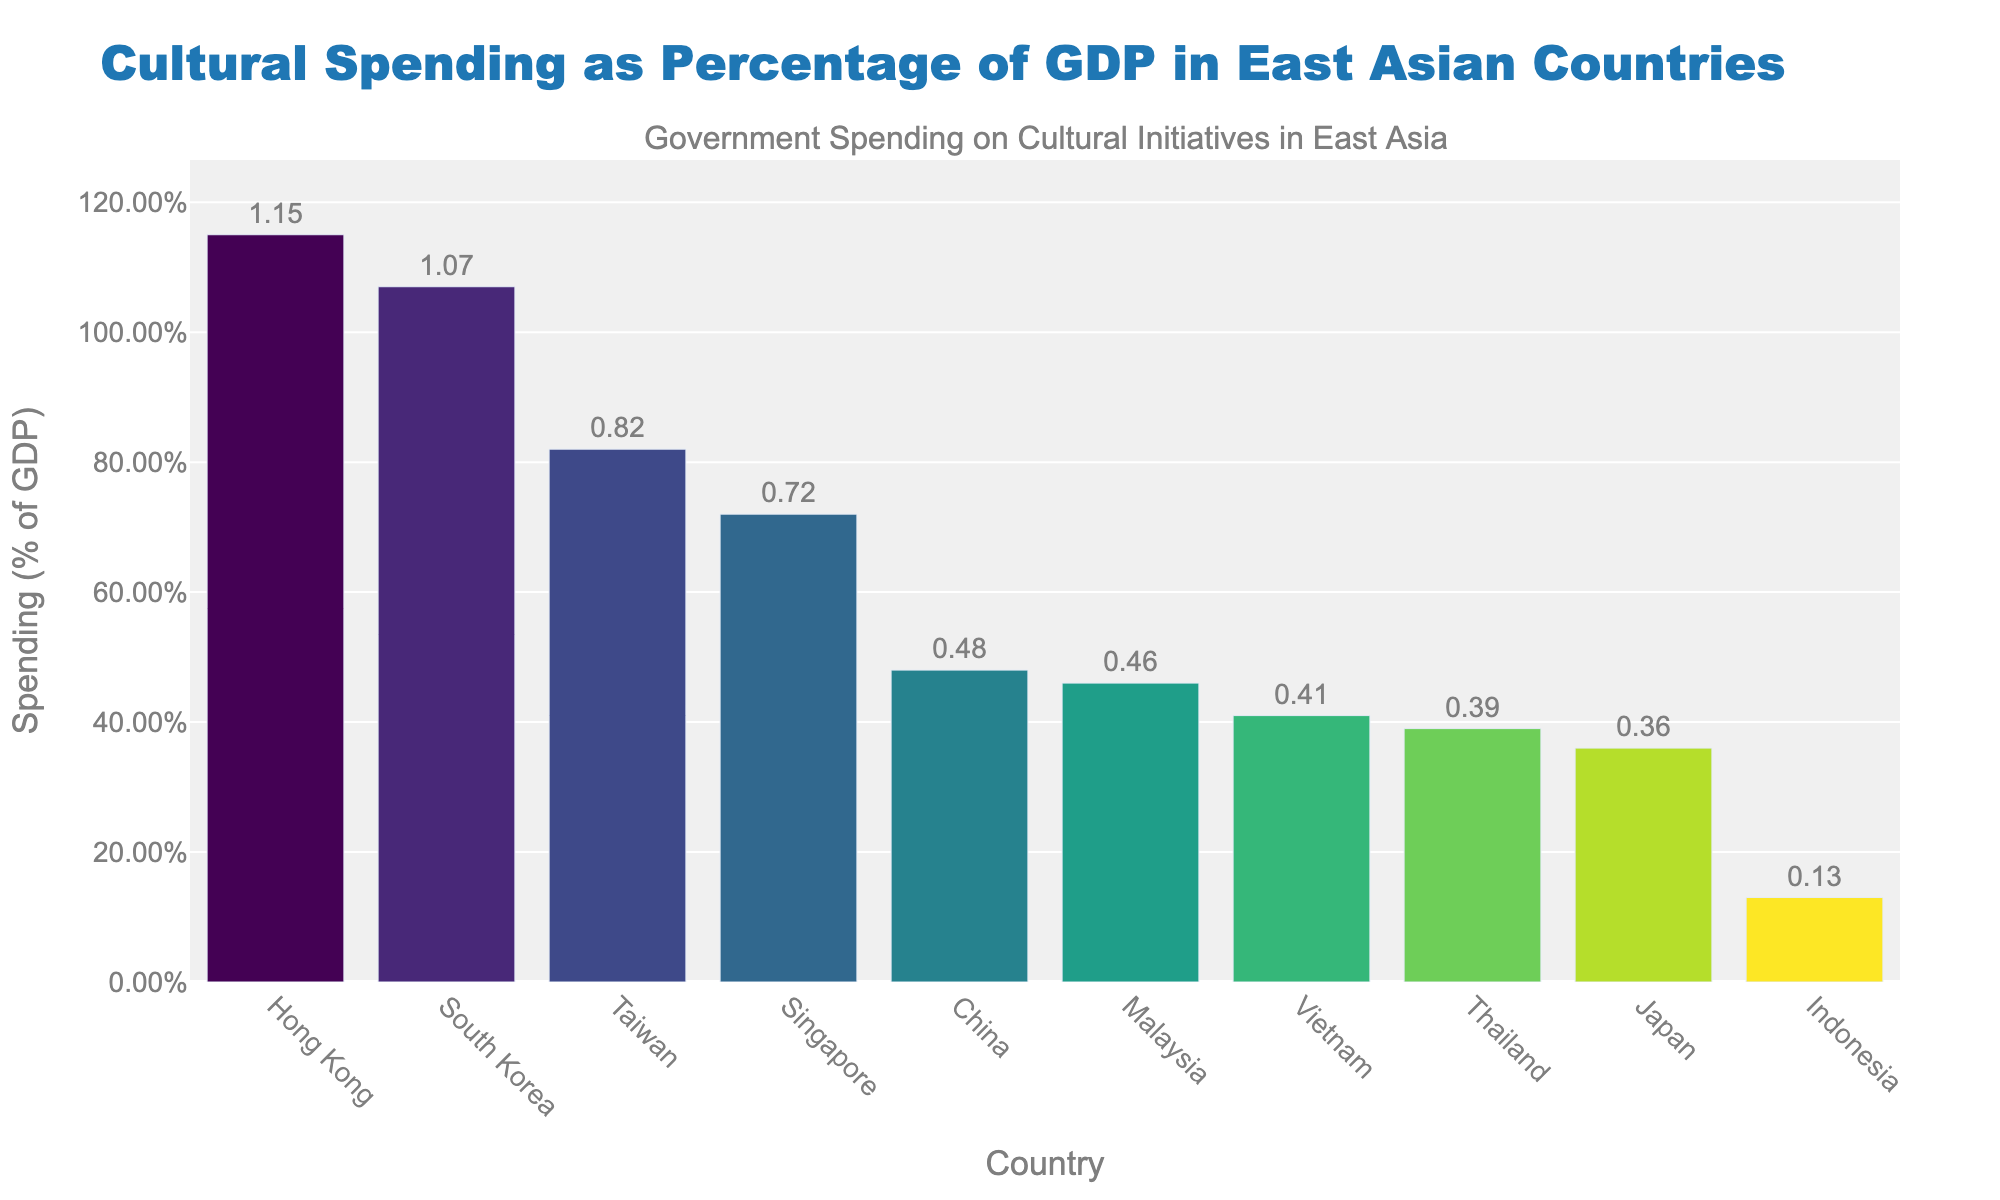What country has the highest government spending on cultural initiatives as a percentage of GDP? The country with the tallest bar represents the highest spending. Hong Kong has the tallest bar.
Answer: Hong Kong Which country has the lowest government spending on cultural initiatives as a percentage of GDP? The country with the shortest bar represents the lowest spending. Indonesia has the shortest bar.
Answer: Indonesia What is the difference in government spending on cultural initiatives between South Korea and Japan? Find the heights of the bars for South Korea (1.07%) and Japan (0.36%) and subtract the smaller from the larger. 1.07% - 0.36% = 0.71%.
Answer: 0.71% Which countries have government spending close to 0.4% of GDP? Look for bars around the 0.4% mark. Vietnam (0.41%), Thailand (0.39%), and Malaysia (0.46%) are close to this value.
Answer: Vietnam, Thailand, Malaysia What is the average government spending on cultural initiatives for China, Japan, and South Korea? Add the values for China (0.48%), Japan (0.36%), and South Korea (1.07%), then divide by 3. (0.48% + 0.36% + 1.07%) / 3 = 0.6367%.
Answer: 0.64% How much more does Hong Kong spend on cultural initiatives compared to Vietnam? Find the heights of the bars for Hong Kong (1.15%) and Vietnam (0.41%) and subtract the smaller from the larger. 1.15% - 0.41% = 0.74%.
Answer: 0.74% Which country has a government spending on cultural initiatives that is greater than Taiwan but less than South Korea? Look for bars where spending is more than Taiwan's (0.82%) but less than South Korea's (1.07%). Singapore (0.72%) fits this range.
Answer: Singapore Arrange the countries from highest to lowest spending on cultural initiatives. Order the countries based on the height of their bars from tallest to shortest. Hong Kong, South Korea, Taiwan, Singapore, China, Malaysia, Vietnam, Thailand, Japan, and Indonesia.
Answer: Hong Kong, South Korea, Taiwan, Singapore, China, Malaysia, Vietnam, Thailand, Japan, Indonesia 